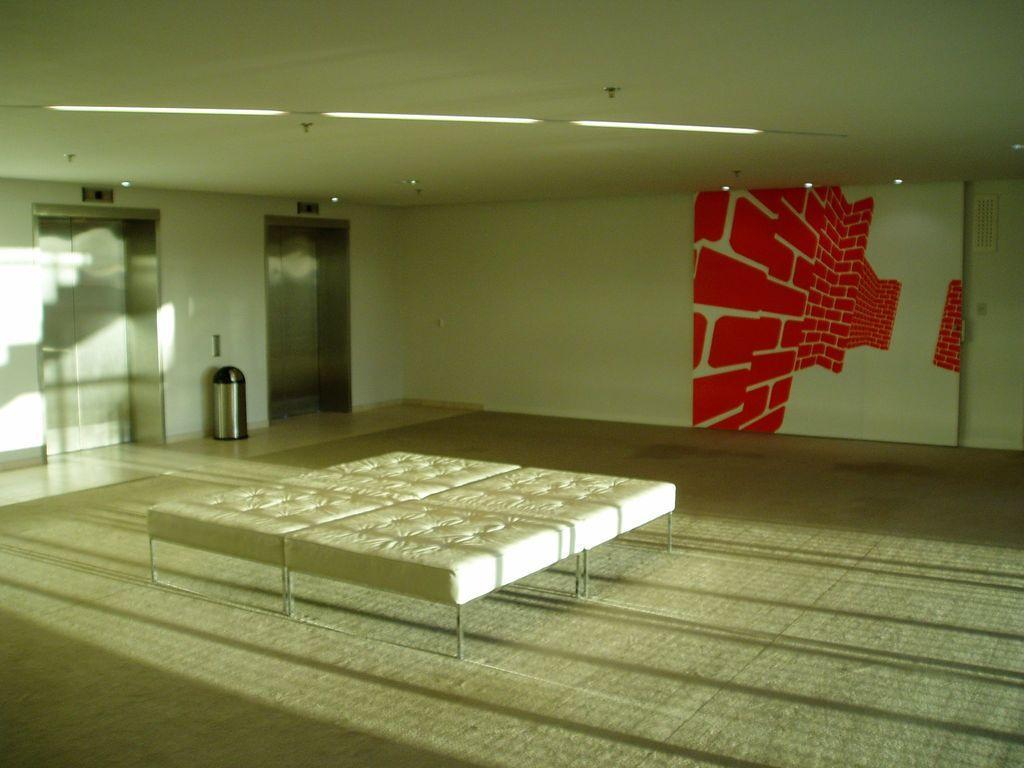Can you describe this image briefly? In this image we can see mattress on the floor, here we can see the wall art, lift lobby, trash can and ceiling lights. 